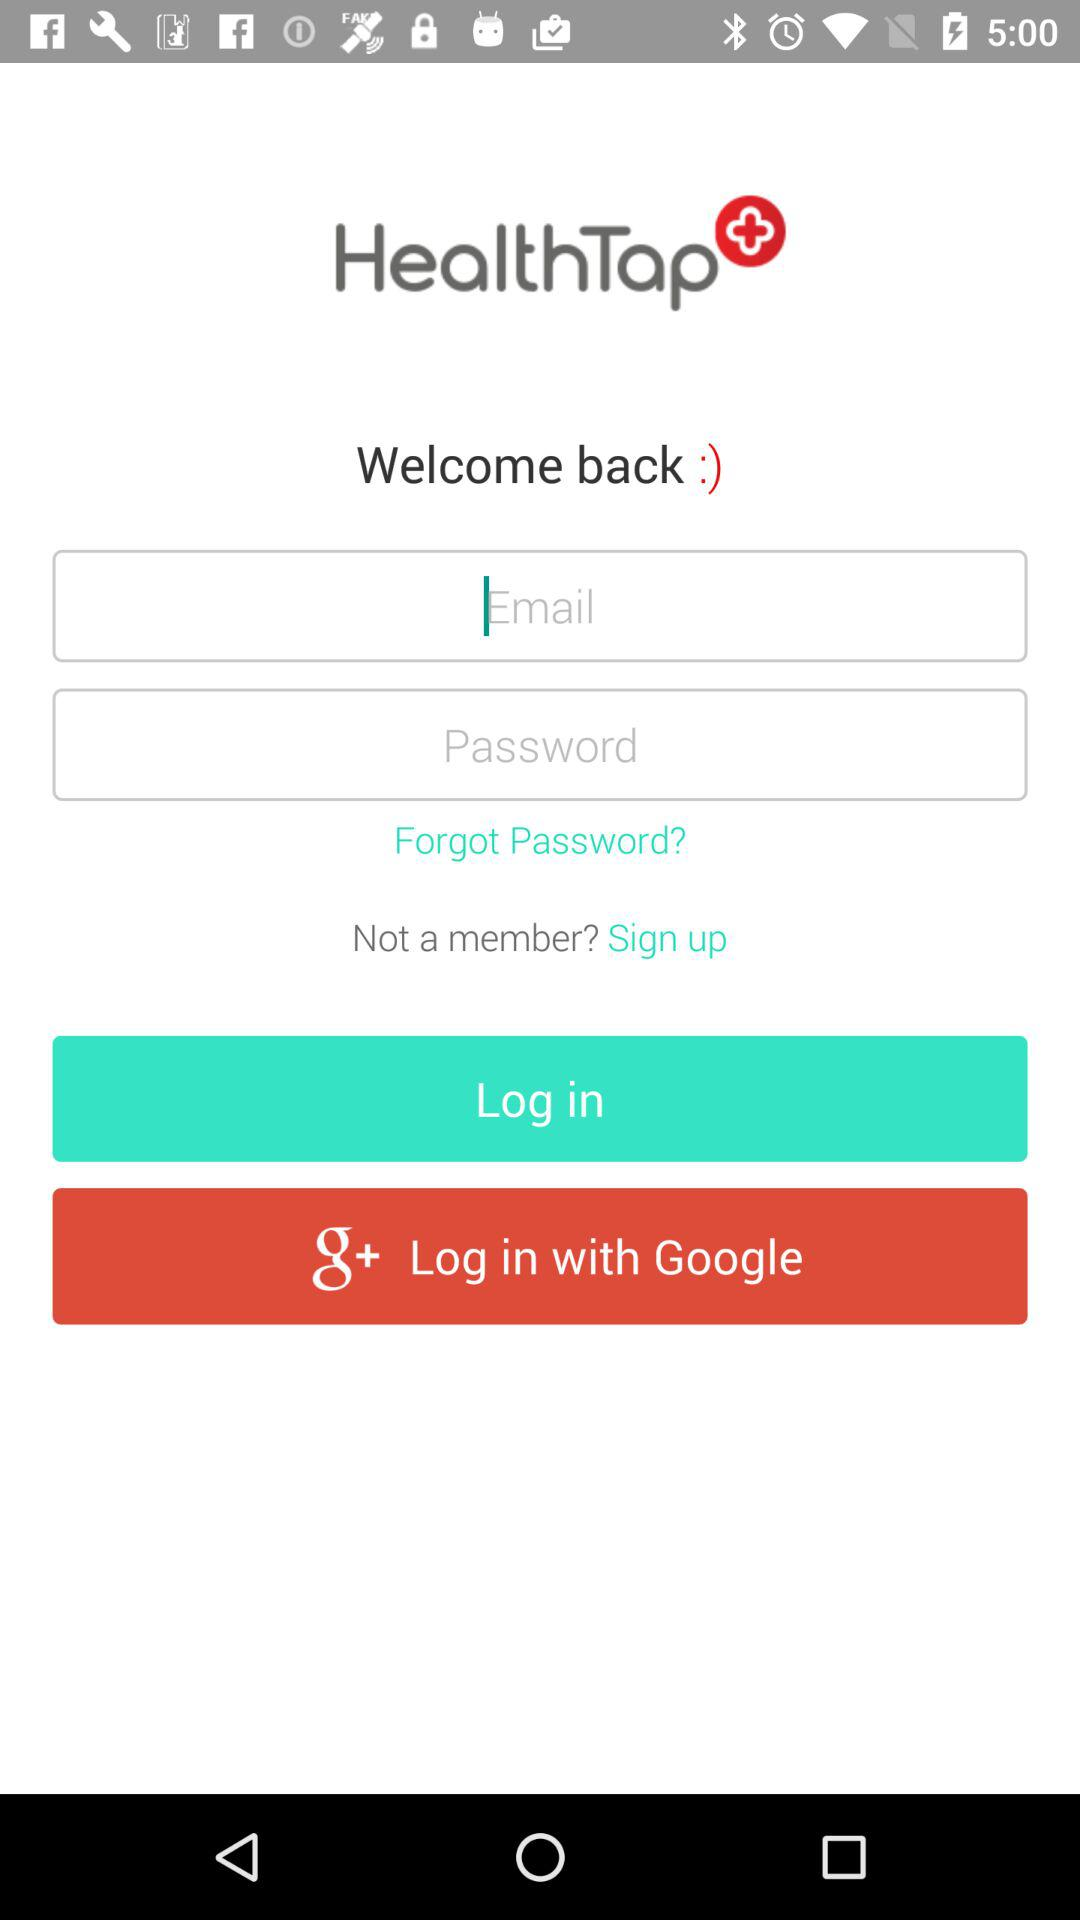How many fields are there for logging in?
Answer the question using a single word or phrase. 2 